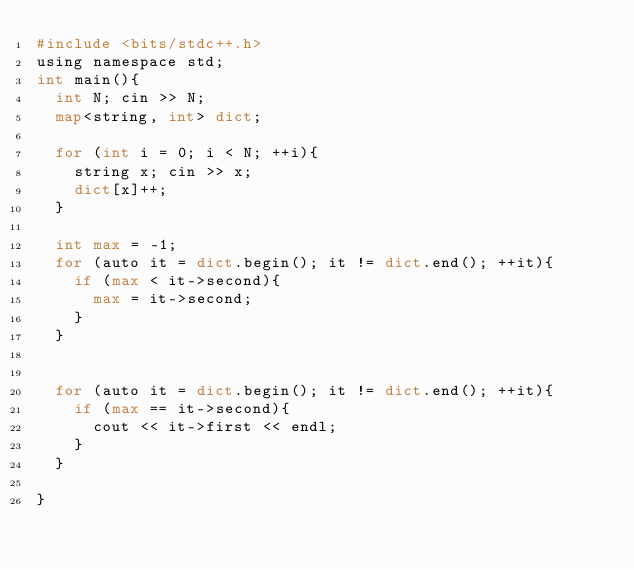<code> <loc_0><loc_0><loc_500><loc_500><_Python_>#include <bits/stdc++.h>
using namespace std;
int main(){
  int N; cin >> N;
  map<string, int> dict;
  
  for (int i = 0; i < N; ++i){
    string x; cin >> x;
    dict[x]++;
  }
  
  int max = -1;
  for (auto it = dict.begin(); it != dict.end(); ++it){
    if (max < it->second){
      max = it->second;
    }
  }
 
  
  for (auto it = dict.begin(); it != dict.end(); ++it){
    if (max == it->second){
      cout << it->first << endl;
    }
  }

}</code> 